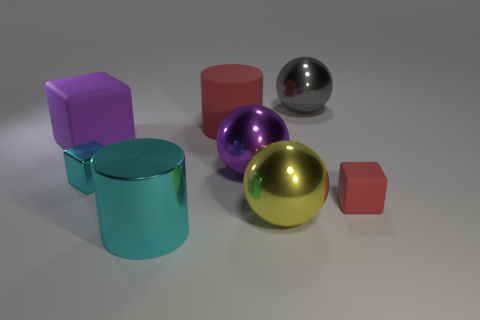Add 2 red metallic spheres. How many objects exist? 10 Subtract all purple shiny balls. How many balls are left? 2 Subtract 2 balls. How many balls are left? 1 Subtract all cylinders. How many objects are left? 6 Subtract all yellow spheres. How many spheres are left? 2 Subtract 0 green cubes. How many objects are left? 8 Subtract all blue cubes. Subtract all purple balls. How many cubes are left? 3 Subtract all green balls. How many cyan cylinders are left? 1 Subtract all small green matte things. Subtract all metal spheres. How many objects are left? 5 Add 2 big purple balls. How many big purple balls are left? 3 